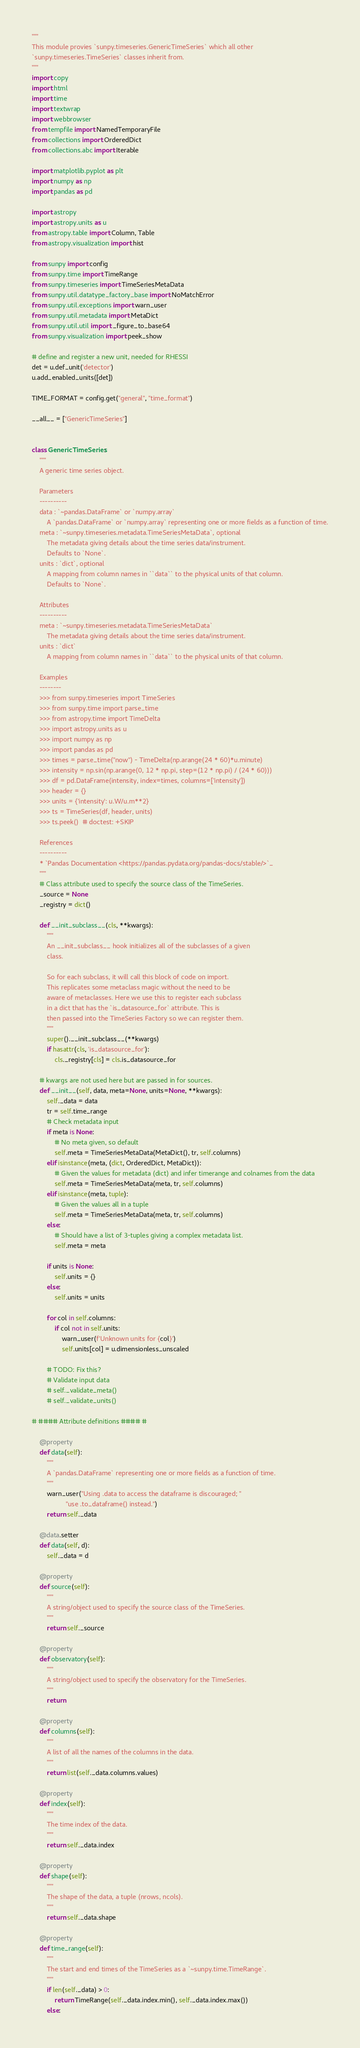<code> <loc_0><loc_0><loc_500><loc_500><_Python_>"""
This module provies `sunpy.timeseries.GenericTimeSeries` which all other
`sunpy.timeseries.TimeSeries` classes inherit from.
"""
import copy
import html
import time
import textwrap
import webbrowser
from tempfile import NamedTemporaryFile
from collections import OrderedDict
from collections.abc import Iterable

import matplotlib.pyplot as plt
import numpy as np
import pandas as pd

import astropy
import astropy.units as u
from astropy.table import Column, Table
from astropy.visualization import hist

from sunpy import config
from sunpy.time import TimeRange
from sunpy.timeseries import TimeSeriesMetaData
from sunpy.util.datatype_factory_base import NoMatchError
from sunpy.util.exceptions import warn_user
from sunpy.util.metadata import MetaDict
from sunpy.util.util import _figure_to_base64
from sunpy.visualization import peek_show

# define and register a new unit, needed for RHESSI
det = u.def_unit('detector')
u.add_enabled_units([det])

TIME_FORMAT = config.get("general", "time_format")

__all__ = ["GenericTimeSeries"]


class GenericTimeSeries:
    """
    A generic time series object.

    Parameters
    ----------
    data : `~pandas.DataFrame` or `numpy.array`
        A `pandas.DataFrame` or `numpy.array` representing one or more fields as a function of time.
    meta : `~sunpy.timeseries.metadata.TimeSeriesMetaData`, optional
        The metadata giving details about the time series data/instrument.
        Defaults to `None`.
    units : `dict`, optional
        A mapping from column names in ``data`` to the physical units of that column.
        Defaults to `None`.

    Attributes
    ----------
    meta : `~sunpy.timeseries.metadata.TimeSeriesMetaData`
        The metadata giving details about the time series data/instrument.
    units : `dict`
        A mapping from column names in ``data`` to the physical units of that column.

    Examples
    --------
    >>> from sunpy.timeseries import TimeSeries
    >>> from sunpy.time import parse_time
    >>> from astropy.time import TimeDelta
    >>> import astropy.units as u
    >>> import numpy as np
    >>> import pandas as pd
    >>> times = parse_time("now") - TimeDelta(np.arange(24 * 60)*u.minute)
    >>> intensity = np.sin(np.arange(0, 12 * np.pi, step=(12 * np.pi) / (24 * 60)))
    >>> df = pd.DataFrame(intensity, index=times, columns=['intensity'])
    >>> header = {}
    >>> units = {'intensity': u.W/u.m**2}
    >>> ts = TimeSeries(df, header, units)
    >>> ts.peek()  # doctest: +SKIP

    References
    ----------
    * `Pandas Documentation <https://pandas.pydata.org/pandas-docs/stable/>`_
    """
    # Class attribute used to specify the source class of the TimeSeries.
    _source = None
    _registry = dict()

    def __init_subclass__(cls, **kwargs):
        """
        An __init_subclass__ hook initializes all of the subclasses of a given
        class.

        So for each subclass, it will call this block of code on import.
        This replicates some metaclass magic without the need to be
        aware of metaclasses. Here we use this to register each subclass
        in a dict that has the `is_datasource_for` attribute. This is
        then passed into the TimeSeries Factory so we can register them.
        """
        super().__init_subclass__(**kwargs)
        if hasattr(cls, 'is_datasource_for'):
            cls._registry[cls] = cls.is_datasource_for

    # kwargs are not used here but are passed in for sources.
    def __init__(self, data, meta=None, units=None, **kwargs):
        self._data = data
        tr = self.time_range
        # Check metadata input
        if meta is None:
            # No meta given, so default
            self.meta = TimeSeriesMetaData(MetaDict(), tr, self.columns)
        elif isinstance(meta, (dict, OrderedDict, MetaDict)):
            # Given the values for metadata (dict) and infer timerange and colnames from the data
            self.meta = TimeSeriesMetaData(meta, tr, self.columns)
        elif isinstance(meta, tuple):
            # Given the values all in a tuple
            self.meta = TimeSeriesMetaData(meta, tr, self.columns)
        else:
            # Should have a list of 3-tuples giving a complex metadata list.
            self.meta = meta

        if units is None:
            self.units = {}
        else:
            self.units = units

        for col in self.columns:
            if col not in self.units:
                warn_user(f'Unknown units for {col}')
                self.units[col] = u.dimensionless_unscaled

        # TODO: Fix this?
        # Validate input data
        # self._validate_meta()
        # self._validate_units()

# #### Attribute definitions #### #

    @property
    def data(self):
        """
        A `pandas.DataFrame` representing one or more fields as a function of time.
        """
        warn_user("Using .data to access the dataframe is discouraged; "
                  "use .to_dataframe() instead.")
        return self._data

    @data.setter
    def data(self, d):
        self._data = d

    @property
    def source(self):
        """
        A string/object used to specify the source class of the TimeSeries.
        """
        return self._source

    @property
    def observatory(self):
        """
        A string/object used to specify the observatory for the TimeSeries.
        """
        return

    @property
    def columns(self):
        """
        A list of all the names of the columns in the data.
        """
        return list(self._data.columns.values)

    @property
    def index(self):
        """
        The time index of the data.
        """
        return self._data.index

    @property
    def shape(self):
        """
        The shape of the data, a tuple (nrows, ncols).
        """
        return self._data.shape

    @property
    def time_range(self):
        """
        The start and end times of the TimeSeries as a `~sunpy.time.TimeRange`.
        """
        if len(self._data) > 0:
            return TimeRange(self._data.index.min(), self._data.index.max())
        else:</code> 